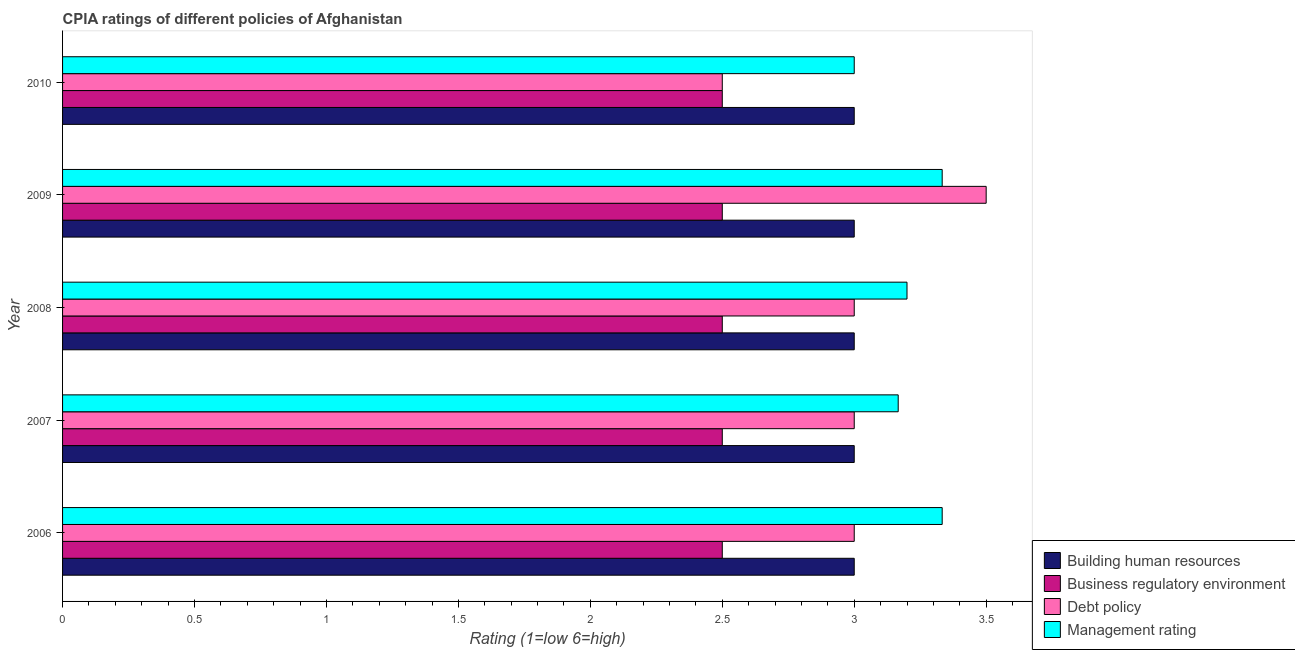How many different coloured bars are there?
Keep it short and to the point. 4. How many groups of bars are there?
Offer a very short reply. 5. Are the number of bars per tick equal to the number of legend labels?
Your answer should be compact. Yes. What is the label of the 4th group of bars from the top?
Keep it short and to the point. 2007. In how many cases, is the number of bars for a given year not equal to the number of legend labels?
Your response must be concise. 0. What is the cpia rating of management in 2010?
Offer a terse response. 3. Across all years, what is the maximum cpia rating of building human resources?
Make the answer very short. 3. In which year was the cpia rating of management maximum?
Give a very brief answer. 2006. What is the total cpia rating of building human resources in the graph?
Your response must be concise. 15. What is the difference between the cpia rating of management in 2006 and that in 2008?
Your response must be concise. 0.13. What is the difference between the cpia rating of management in 2007 and the cpia rating of debt policy in 2008?
Your answer should be compact. 0.17. In how many years, is the cpia rating of building human resources greater than 0.9 ?
Give a very brief answer. 5. Is the difference between the cpia rating of business regulatory environment in 2006 and 2009 greater than the difference between the cpia rating of management in 2006 and 2009?
Provide a succinct answer. No. In how many years, is the cpia rating of business regulatory environment greater than the average cpia rating of business regulatory environment taken over all years?
Your answer should be compact. 0. Is it the case that in every year, the sum of the cpia rating of building human resources and cpia rating of debt policy is greater than the sum of cpia rating of business regulatory environment and cpia rating of management?
Provide a succinct answer. No. What does the 3rd bar from the top in 2007 represents?
Offer a terse response. Business regulatory environment. What does the 4th bar from the bottom in 2010 represents?
Provide a short and direct response. Management rating. Is it the case that in every year, the sum of the cpia rating of building human resources and cpia rating of business regulatory environment is greater than the cpia rating of debt policy?
Offer a very short reply. Yes. How many years are there in the graph?
Your response must be concise. 5. What is the difference between two consecutive major ticks on the X-axis?
Provide a succinct answer. 0.5. Does the graph contain any zero values?
Your answer should be compact. No. Does the graph contain grids?
Offer a very short reply. No. Where does the legend appear in the graph?
Make the answer very short. Bottom right. How are the legend labels stacked?
Your answer should be very brief. Vertical. What is the title of the graph?
Give a very brief answer. CPIA ratings of different policies of Afghanistan. Does "Taxes on goods and services" appear as one of the legend labels in the graph?
Keep it short and to the point. No. What is the label or title of the Y-axis?
Your answer should be compact. Year. What is the Rating (1=low 6=high) of Debt policy in 2006?
Ensure brevity in your answer.  3. What is the Rating (1=low 6=high) in Management rating in 2006?
Offer a terse response. 3.33. What is the Rating (1=low 6=high) in Building human resources in 2007?
Your answer should be very brief. 3. What is the Rating (1=low 6=high) in Business regulatory environment in 2007?
Keep it short and to the point. 2.5. What is the Rating (1=low 6=high) of Management rating in 2007?
Offer a terse response. 3.17. What is the Rating (1=low 6=high) in Management rating in 2008?
Your answer should be very brief. 3.2. What is the Rating (1=low 6=high) of Building human resources in 2009?
Ensure brevity in your answer.  3. What is the Rating (1=low 6=high) in Business regulatory environment in 2009?
Your response must be concise. 2.5. What is the Rating (1=low 6=high) in Debt policy in 2009?
Your response must be concise. 3.5. What is the Rating (1=low 6=high) of Management rating in 2009?
Provide a succinct answer. 3.33. What is the Rating (1=low 6=high) of Building human resources in 2010?
Keep it short and to the point. 3. What is the Rating (1=low 6=high) of Debt policy in 2010?
Offer a very short reply. 2.5. What is the Rating (1=low 6=high) of Management rating in 2010?
Keep it short and to the point. 3. Across all years, what is the maximum Rating (1=low 6=high) in Business regulatory environment?
Make the answer very short. 2.5. Across all years, what is the maximum Rating (1=low 6=high) in Management rating?
Give a very brief answer. 3.33. Across all years, what is the minimum Rating (1=low 6=high) in Building human resources?
Give a very brief answer. 3. Across all years, what is the minimum Rating (1=low 6=high) in Business regulatory environment?
Offer a very short reply. 2.5. Across all years, what is the minimum Rating (1=low 6=high) in Management rating?
Your answer should be very brief. 3. What is the total Rating (1=low 6=high) of Business regulatory environment in the graph?
Your answer should be very brief. 12.5. What is the total Rating (1=low 6=high) of Debt policy in the graph?
Make the answer very short. 15. What is the total Rating (1=low 6=high) in Management rating in the graph?
Give a very brief answer. 16.03. What is the difference between the Rating (1=low 6=high) in Building human resources in 2006 and that in 2007?
Your response must be concise. 0. What is the difference between the Rating (1=low 6=high) of Debt policy in 2006 and that in 2007?
Provide a succinct answer. 0. What is the difference between the Rating (1=low 6=high) of Management rating in 2006 and that in 2007?
Give a very brief answer. 0.17. What is the difference between the Rating (1=low 6=high) in Building human resources in 2006 and that in 2008?
Your answer should be very brief. 0. What is the difference between the Rating (1=low 6=high) of Business regulatory environment in 2006 and that in 2008?
Provide a succinct answer. 0. What is the difference between the Rating (1=low 6=high) of Debt policy in 2006 and that in 2008?
Offer a very short reply. 0. What is the difference between the Rating (1=low 6=high) of Management rating in 2006 and that in 2008?
Your answer should be compact. 0.13. What is the difference between the Rating (1=low 6=high) in Debt policy in 2006 and that in 2009?
Your answer should be compact. -0.5. What is the difference between the Rating (1=low 6=high) in Debt policy in 2006 and that in 2010?
Give a very brief answer. 0.5. What is the difference between the Rating (1=low 6=high) of Building human resources in 2007 and that in 2008?
Make the answer very short. 0. What is the difference between the Rating (1=low 6=high) of Business regulatory environment in 2007 and that in 2008?
Offer a very short reply. 0. What is the difference between the Rating (1=low 6=high) in Debt policy in 2007 and that in 2008?
Your response must be concise. 0. What is the difference between the Rating (1=low 6=high) in Management rating in 2007 and that in 2008?
Your response must be concise. -0.03. What is the difference between the Rating (1=low 6=high) in Debt policy in 2007 and that in 2009?
Keep it short and to the point. -0.5. What is the difference between the Rating (1=low 6=high) in Building human resources in 2007 and that in 2010?
Keep it short and to the point. 0. What is the difference between the Rating (1=low 6=high) in Debt policy in 2008 and that in 2009?
Your answer should be very brief. -0.5. What is the difference between the Rating (1=low 6=high) in Management rating in 2008 and that in 2009?
Provide a short and direct response. -0.13. What is the difference between the Rating (1=low 6=high) of Building human resources in 2008 and that in 2010?
Keep it short and to the point. 0. What is the difference between the Rating (1=low 6=high) of Management rating in 2008 and that in 2010?
Ensure brevity in your answer.  0.2. What is the difference between the Rating (1=low 6=high) in Building human resources in 2006 and the Rating (1=low 6=high) in Business regulatory environment in 2007?
Your response must be concise. 0.5. What is the difference between the Rating (1=low 6=high) in Building human resources in 2006 and the Rating (1=low 6=high) in Debt policy in 2007?
Give a very brief answer. 0. What is the difference between the Rating (1=low 6=high) in Business regulatory environment in 2006 and the Rating (1=low 6=high) in Debt policy in 2007?
Provide a short and direct response. -0.5. What is the difference between the Rating (1=low 6=high) in Business regulatory environment in 2006 and the Rating (1=low 6=high) in Management rating in 2007?
Your answer should be very brief. -0.67. What is the difference between the Rating (1=low 6=high) in Business regulatory environment in 2006 and the Rating (1=low 6=high) in Management rating in 2008?
Your answer should be compact. -0.7. What is the difference between the Rating (1=low 6=high) of Debt policy in 2006 and the Rating (1=low 6=high) of Management rating in 2008?
Ensure brevity in your answer.  -0.2. What is the difference between the Rating (1=low 6=high) of Business regulatory environment in 2006 and the Rating (1=low 6=high) of Management rating in 2009?
Offer a very short reply. -0.83. What is the difference between the Rating (1=low 6=high) of Building human resources in 2006 and the Rating (1=low 6=high) of Debt policy in 2010?
Give a very brief answer. 0.5. What is the difference between the Rating (1=low 6=high) in Building human resources in 2006 and the Rating (1=low 6=high) in Management rating in 2010?
Make the answer very short. 0. What is the difference between the Rating (1=low 6=high) in Business regulatory environment in 2006 and the Rating (1=low 6=high) in Debt policy in 2010?
Provide a short and direct response. 0. What is the difference between the Rating (1=low 6=high) of Business regulatory environment in 2006 and the Rating (1=low 6=high) of Management rating in 2010?
Offer a very short reply. -0.5. What is the difference between the Rating (1=low 6=high) in Building human resources in 2007 and the Rating (1=low 6=high) in Business regulatory environment in 2008?
Your response must be concise. 0.5. What is the difference between the Rating (1=low 6=high) in Building human resources in 2007 and the Rating (1=low 6=high) in Debt policy in 2008?
Your answer should be very brief. 0. What is the difference between the Rating (1=low 6=high) of Building human resources in 2007 and the Rating (1=low 6=high) of Management rating in 2008?
Give a very brief answer. -0.2. What is the difference between the Rating (1=low 6=high) of Debt policy in 2007 and the Rating (1=low 6=high) of Management rating in 2008?
Provide a short and direct response. -0.2. What is the difference between the Rating (1=low 6=high) of Business regulatory environment in 2007 and the Rating (1=low 6=high) of Debt policy in 2009?
Keep it short and to the point. -1. What is the difference between the Rating (1=low 6=high) of Building human resources in 2007 and the Rating (1=low 6=high) of Business regulatory environment in 2010?
Provide a succinct answer. 0.5. What is the difference between the Rating (1=low 6=high) of Business regulatory environment in 2007 and the Rating (1=low 6=high) of Management rating in 2010?
Ensure brevity in your answer.  -0.5. What is the difference between the Rating (1=low 6=high) of Building human resources in 2008 and the Rating (1=low 6=high) of Business regulatory environment in 2009?
Your answer should be very brief. 0.5. What is the difference between the Rating (1=low 6=high) in Building human resources in 2008 and the Rating (1=low 6=high) in Debt policy in 2009?
Your answer should be compact. -0.5. What is the difference between the Rating (1=low 6=high) in Building human resources in 2008 and the Rating (1=low 6=high) in Management rating in 2009?
Provide a short and direct response. -0.33. What is the difference between the Rating (1=low 6=high) in Business regulatory environment in 2008 and the Rating (1=low 6=high) in Debt policy in 2009?
Provide a short and direct response. -1. What is the difference between the Rating (1=low 6=high) in Debt policy in 2008 and the Rating (1=low 6=high) in Management rating in 2009?
Give a very brief answer. -0.33. What is the difference between the Rating (1=low 6=high) of Building human resources in 2008 and the Rating (1=low 6=high) of Business regulatory environment in 2010?
Provide a short and direct response. 0.5. What is the difference between the Rating (1=low 6=high) in Business regulatory environment in 2008 and the Rating (1=low 6=high) in Debt policy in 2010?
Provide a short and direct response. 0. What is the difference between the Rating (1=low 6=high) of Building human resources in 2009 and the Rating (1=low 6=high) of Debt policy in 2010?
Provide a short and direct response. 0.5. What is the difference between the Rating (1=low 6=high) in Business regulatory environment in 2009 and the Rating (1=low 6=high) in Debt policy in 2010?
Your answer should be very brief. 0. What is the difference between the Rating (1=low 6=high) of Debt policy in 2009 and the Rating (1=low 6=high) of Management rating in 2010?
Ensure brevity in your answer.  0.5. What is the average Rating (1=low 6=high) in Business regulatory environment per year?
Offer a very short reply. 2.5. What is the average Rating (1=low 6=high) of Debt policy per year?
Provide a short and direct response. 3. What is the average Rating (1=low 6=high) in Management rating per year?
Your answer should be very brief. 3.21. In the year 2006, what is the difference between the Rating (1=low 6=high) of Building human resources and Rating (1=low 6=high) of Debt policy?
Ensure brevity in your answer.  0. In the year 2006, what is the difference between the Rating (1=low 6=high) of Building human resources and Rating (1=low 6=high) of Management rating?
Keep it short and to the point. -0.33. In the year 2006, what is the difference between the Rating (1=low 6=high) in Business regulatory environment and Rating (1=low 6=high) in Management rating?
Your answer should be compact. -0.83. In the year 2007, what is the difference between the Rating (1=low 6=high) in Building human resources and Rating (1=low 6=high) in Business regulatory environment?
Make the answer very short. 0.5. In the year 2007, what is the difference between the Rating (1=low 6=high) in Business regulatory environment and Rating (1=low 6=high) in Debt policy?
Your answer should be very brief. -0.5. In the year 2007, what is the difference between the Rating (1=low 6=high) of Business regulatory environment and Rating (1=low 6=high) of Management rating?
Your answer should be compact. -0.67. In the year 2009, what is the difference between the Rating (1=low 6=high) in Business regulatory environment and Rating (1=low 6=high) in Management rating?
Give a very brief answer. -0.83. In the year 2009, what is the difference between the Rating (1=low 6=high) of Debt policy and Rating (1=low 6=high) of Management rating?
Your answer should be compact. 0.17. In the year 2010, what is the difference between the Rating (1=low 6=high) of Building human resources and Rating (1=low 6=high) of Business regulatory environment?
Ensure brevity in your answer.  0.5. In the year 2010, what is the difference between the Rating (1=low 6=high) in Building human resources and Rating (1=low 6=high) in Debt policy?
Ensure brevity in your answer.  0.5. In the year 2010, what is the difference between the Rating (1=low 6=high) of Business regulatory environment and Rating (1=low 6=high) of Debt policy?
Your answer should be compact. 0. In the year 2010, what is the difference between the Rating (1=low 6=high) of Business regulatory environment and Rating (1=low 6=high) of Management rating?
Provide a short and direct response. -0.5. In the year 2010, what is the difference between the Rating (1=low 6=high) of Debt policy and Rating (1=low 6=high) of Management rating?
Ensure brevity in your answer.  -0.5. What is the ratio of the Rating (1=low 6=high) of Debt policy in 2006 to that in 2007?
Keep it short and to the point. 1. What is the ratio of the Rating (1=low 6=high) of Management rating in 2006 to that in 2007?
Offer a very short reply. 1.05. What is the ratio of the Rating (1=low 6=high) in Building human resources in 2006 to that in 2008?
Provide a short and direct response. 1. What is the ratio of the Rating (1=low 6=high) in Business regulatory environment in 2006 to that in 2008?
Provide a succinct answer. 1. What is the ratio of the Rating (1=low 6=high) of Debt policy in 2006 to that in 2008?
Keep it short and to the point. 1. What is the ratio of the Rating (1=low 6=high) of Management rating in 2006 to that in 2008?
Ensure brevity in your answer.  1.04. What is the ratio of the Rating (1=low 6=high) in Building human resources in 2006 to that in 2009?
Your answer should be very brief. 1. What is the ratio of the Rating (1=low 6=high) in Debt policy in 2006 to that in 2009?
Give a very brief answer. 0.86. What is the ratio of the Rating (1=low 6=high) in Management rating in 2006 to that in 2009?
Ensure brevity in your answer.  1. What is the ratio of the Rating (1=low 6=high) of Building human resources in 2006 to that in 2010?
Keep it short and to the point. 1. What is the ratio of the Rating (1=low 6=high) in Management rating in 2006 to that in 2010?
Your answer should be very brief. 1.11. What is the ratio of the Rating (1=low 6=high) in Management rating in 2007 to that in 2008?
Provide a succinct answer. 0.99. What is the ratio of the Rating (1=low 6=high) in Management rating in 2007 to that in 2009?
Your response must be concise. 0.95. What is the ratio of the Rating (1=low 6=high) in Building human resources in 2007 to that in 2010?
Give a very brief answer. 1. What is the ratio of the Rating (1=low 6=high) in Business regulatory environment in 2007 to that in 2010?
Your response must be concise. 1. What is the ratio of the Rating (1=low 6=high) of Debt policy in 2007 to that in 2010?
Offer a terse response. 1.2. What is the ratio of the Rating (1=low 6=high) in Management rating in 2007 to that in 2010?
Your answer should be compact. 1.06. What is the ratio of the Rating (1=low 6=high) in Debt policy in 2008 to that in 2009?
Make the answer very short. 0.86. What is the ratio of the Rating (1=low 6=high) of Management rating in 2008 to that in 2010?
Make the answer very short. 1.07. What is the ratio of the Rating (1=low 6=high) of Building human resources in 2009 to that in 2010?
Offer a terse response. 1. What is the difference between the highest and the second highest Rating (1=low 6=high) of Building human resources?
Provide a short and direct response. 0. What is the difference between the highest and the second highest Rating (1=low 6=high) in Business regulatory environment?
Offer a very short reply. 0. What is the difference between the highest and the second highest Rating (1=low 6=high) in Debt policy?
Make the answer very short. 0.5. 